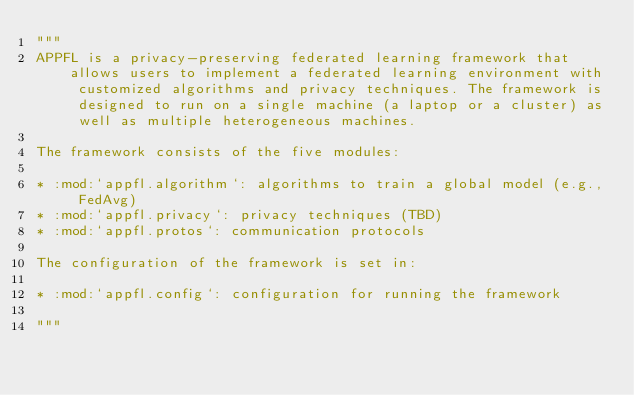Convert code to text. <code><loc_0><loc_0><loc_500><loc_500><_Python_>"""
APPFL is a privacy-preserving federated learning framework that allows users to implement a federated learning environment with customized algorithms and privacy techniques. The framework is designed to run on a single machine (a laptop or a cluster) as well as multiple heterogeneous machines.

The framework consists of the five modules:

* :mod:`appfl.algorithm`: algorithms to train a global model (e.g., FedAvg)
* :mod:`appfl.privacy`: privacy techniques (TBD)
* :mod:`appfl.protos`: communication protocols

The configuration of the framework is set in:

* :mod:`appfl.config`: configuration for running the framework

"""</code> 